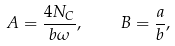Convert formula to latex. <formula><loc_0><loc_0><loc_500><loc_500>A = \frac { 4 N _ { C } } { b \omega } , \quad B = \frac { a } { b } ,</formula> 